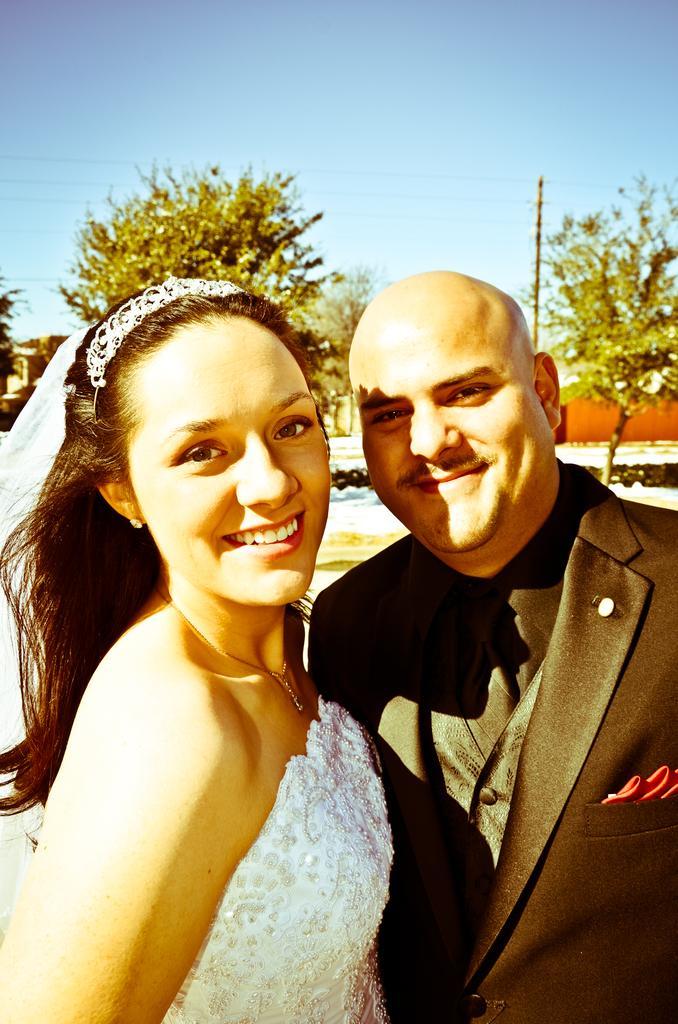Describe this image in one or two sentences. There is a couple standing in front of the camera and posing for the photo, they are smiling and behind the couple there are some trees and wires to the pole, in the background there is the sky. 